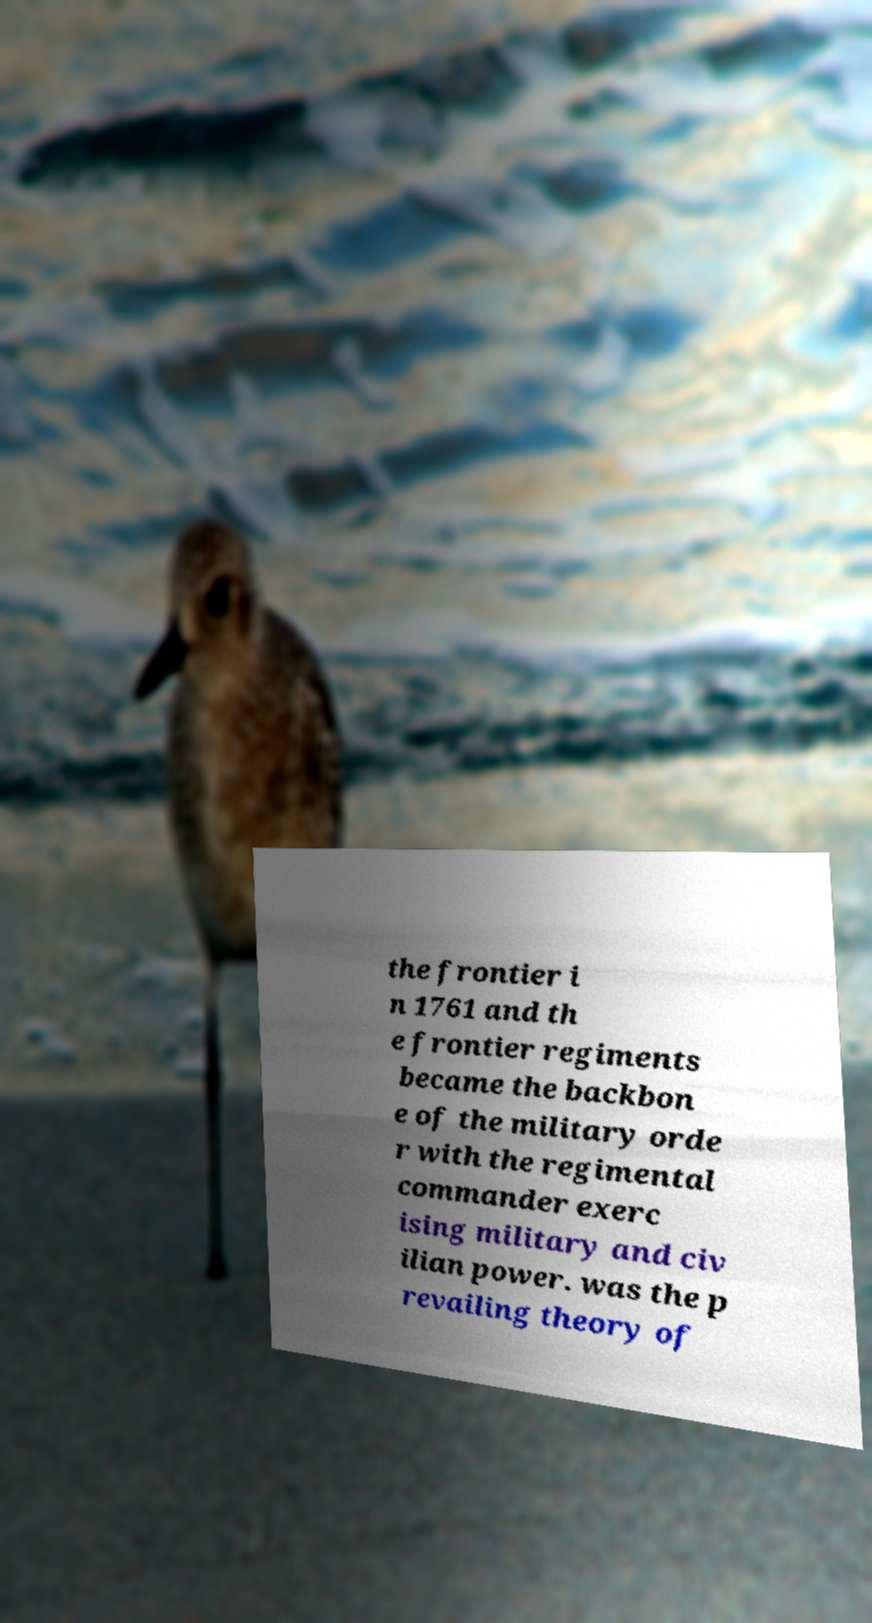Could you assist in decoding the text presented in this image and type it out clearly? the frontier i n 1761 and th e frontier regiments became the backbon e of the military orde r with the regimental commander exerc ising military and civ ilian power. was the p revailing theory of 